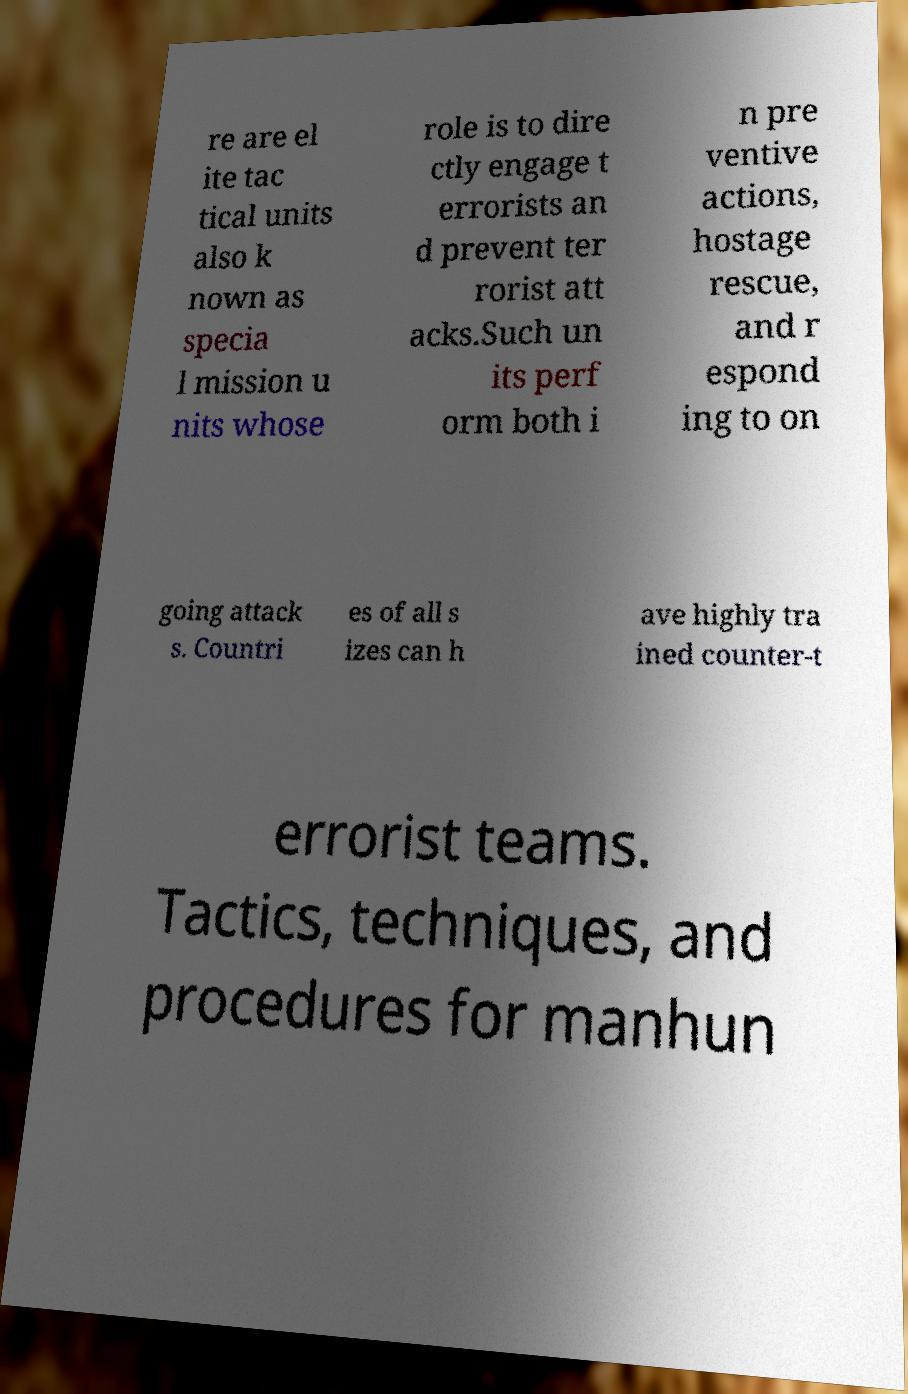Can you accurately transcribe the text from the provided image for me? re are el ite tac tical units also k nown as specia l mission u nits whose role is to dire ctly engage t errorists an d prevent ter rorist att acks.Such un its perf orm both i n pre ventive actions, hostage rescue, and r espond ing to on going attack s. Countri es of all s izes can h ave highly tra ined counter-t errorist teams. Tactics, techniques, and procedures for manhun 